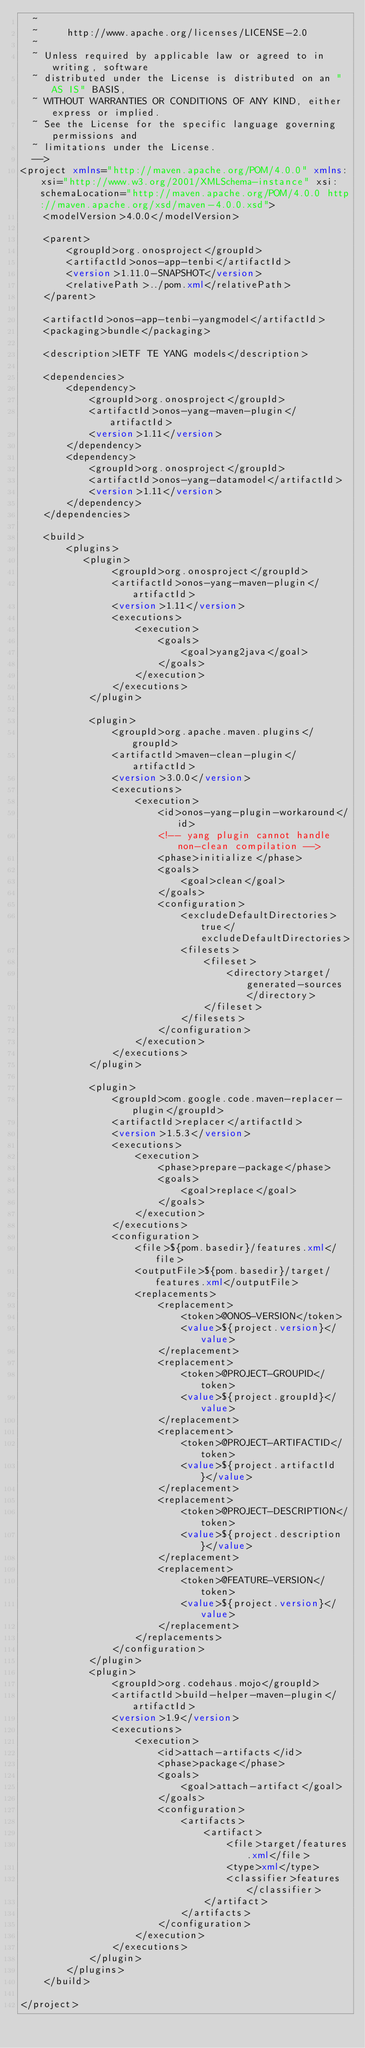Convert code to text. <code><loc_0><loc_0><loc_500><loc_500><_XML_>  ~
  ~     http://www.apache.org/licenses/LICENSE-2.0
  ~
  ~ Unless required by applicable law or agreed to in writing, software
  ~ distributed under the License is distributed on an "AS IS" BASIS,
  ~ WITHOUT WARRANTIES OR CONDITIONS OF ANY KIND, either express or implied.
  ~ See the License for the specific language governing permissions and
  ~ limitations under the License.
  -->
<project xmlns="http://maven.apache.org/POM/4.0.0" xmlns:xsi="http://www.w3.org/2001/XMLSchema-instance" xsi:schemaLocation="http://maven.apache.org/POM/4.0.0 http://maven.apache.org/xsd/maven-4.0.0.xsd">
    <modelVersion>4.0.0</modelVersion>

    <parent>
        <groupId>org.onosproject</groupId>
        <artifactId>onos-app-tenbi</artifactId>
        <version>1.11.0-SNAPSHOT</version>
        <relativePath>../pom.xml</relativePath>
    </parent>

    <artifactId>onos-app-tenbi-yangmodel</artifactId>
    <packaging>bundle</packaging>

    <description>IETF TE YANG models</description>

    <dependencies>
        <dependency>
            <groupId>org.onosproject</groupId>
            <artifactId>onos-yang-maven-plugin</artifactId>
            <version>1.11</version>
        </dependency>
        <dependency>
            <groupId>org.onosproject</groupId>
            <artifactId>onos-yang-datamodel</artifactId>
            <version>1.11</version>
        </dependency>
    </dependencies>

    <build>
        <plugins>
           <plugin>
                <groupId>org.onosproject</groupId>
                <artifactId>onos-yang-maven-plugin</artifactId>
                <version>1.11</version>
                <executions>
                    <execution>
                        <goals>
                            <goal>yang2java</goal>
                        </goals>
                    </execution>
                </executions>
            </plugin>

            <plugin>
                <groupId>org.apache.maven.plugins</groupId>
                <artifactId>maven-clean-plugin</artifactId>
                <version>3.0.0</version>
                <executions>
                    <execution>
                        <id>onos-yang-plugin-workaround</id>
                        <!-- yang plugin cannot handle non-clean compilation -->
                        <phase>initialize</phase>
                        <goals>
                            <goal>clean</goal>
                        </goals>
                        <configuration>
                            <excludeDefaultDirectories>true</excludeDefaultDirectories>
                            <filesets>
                                <fileset>
                                    <directory>target/generated-sources</directory>
                                </fileset>
                            </filesets>
                        </configuration>
                    </execution>
                </executions>
            </plugin>

            <plugin>
                <groupId>com.google.code.maven-replacer-plugin</groupId>
                <artifactId>replacer</artifactId>
                <version>1.5.3</version>
                <executions>
                    <execution>
                        <phase>prepare-package</phase>
                        <goals>
                            <goal>replace</goal>
                        </goals>
                    </execution>
                </executions>
                <configuration>
                    <file>${pom.basedir}/features.xml</file>
                    <outputFile>${pom.basedir}/target/features.xml</outputFile>
                    <replacements>
                        <replacement>
                            <token>@ONOS-VERSION</token>
                            <value>${project.version}</value>
                        </replacement>
                        <replacement>
                            <token>@PROJECT-GROUPID</token>
                            <value>${project.groupId}</value>
                        </replacement>
                        <replacement>
                            <token>@PROJECT-ARTIFACTID</token>
                            <value>${project.artifactId}</value>
                        </replacement>
                        <replacement>
                            <token>@PROJECT-DESCRIPTION</token>
                            <value>${project.description}</value>
                        </replacement>
                        <replacement>
                            <token>@FEATURE-VERSION</token>
                            <value>${project.version}</value>
                        </replacement>
                    </replacements>
                </configuration>
            </plugin>
            <plugin>
                <groupId>org.codehaus.mojo</groupId>
                <artifactId>build-helper-maven-plugin</artifactId>
                <version>1.9</version>
                <executions>
                    <execution>
                        <id>attach-artifacts</id>
                        <phase>package</phase>
                        <goals>
                            <goal>attach-artifact</goal>
                        </goals>
                        <configuration>
                            <artifacts>
                                <artifact>
                                    <file>target/features.xml</file>
                                    <type>xml</type>
                                    <classifier>features</classifier>
                                </artifact>
                            </artifacts>
                        </configuration>
                    </execution>
                </executions>
            </plugin>
        </plugins>
    </build>

</project>
</code> 